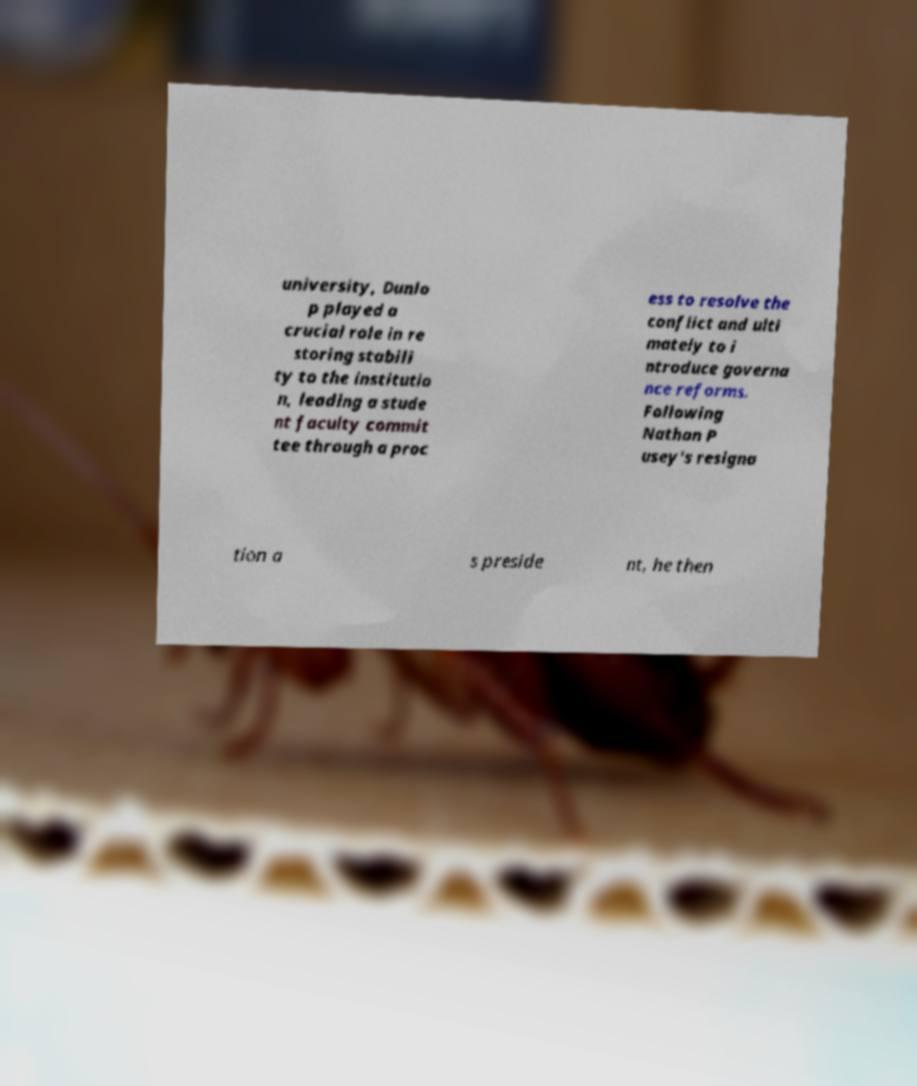Please identify and transcribe the text found in this image. university, Dunlo p played a crucial role in re storing stabili ty to the institutio n, leading a stude nt faculty commit tee through a proc ess to resolve the conflict and ulti mately to i ntroduce governa nce reforms. Following Nathan P usey's resigna tion a s preside nt, he then 